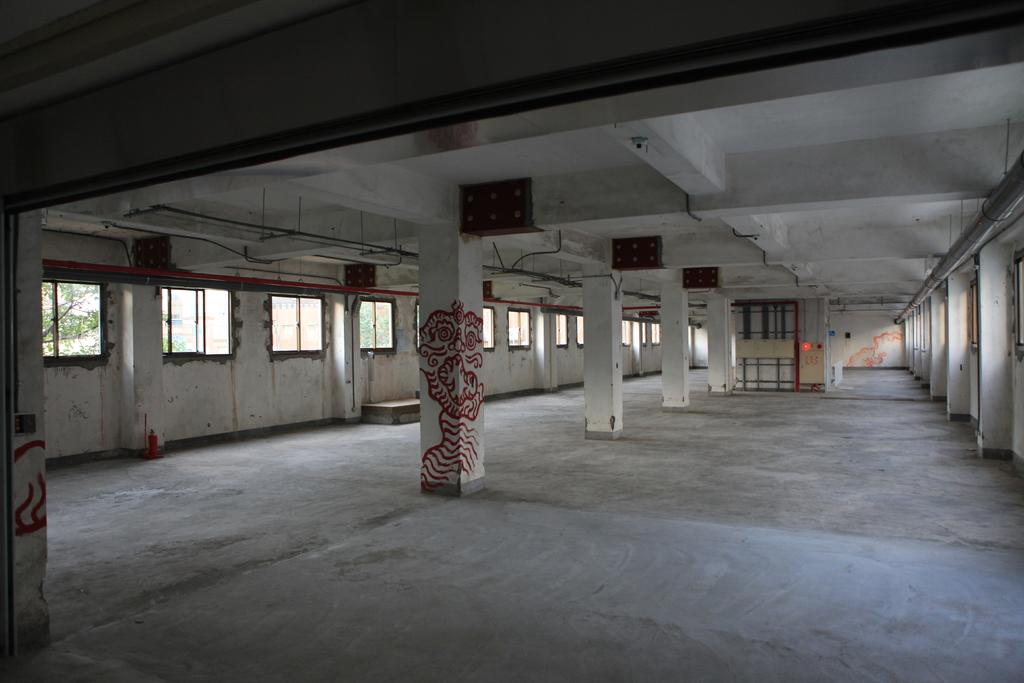What architectural features are present in the image? There are pillars in the image. What can be seen through the windows in the image? The image does not show what can be seen through the windows. What type of material is used for the objects in the background of the image? There are wooden objects in the background of the image. What is depicted on one of the pillars in the image? There is a painting on a pillar in the image. What type of skirt is the pillar wearing in the image? Pillars do not wear skirts; they are inanimate objects. 